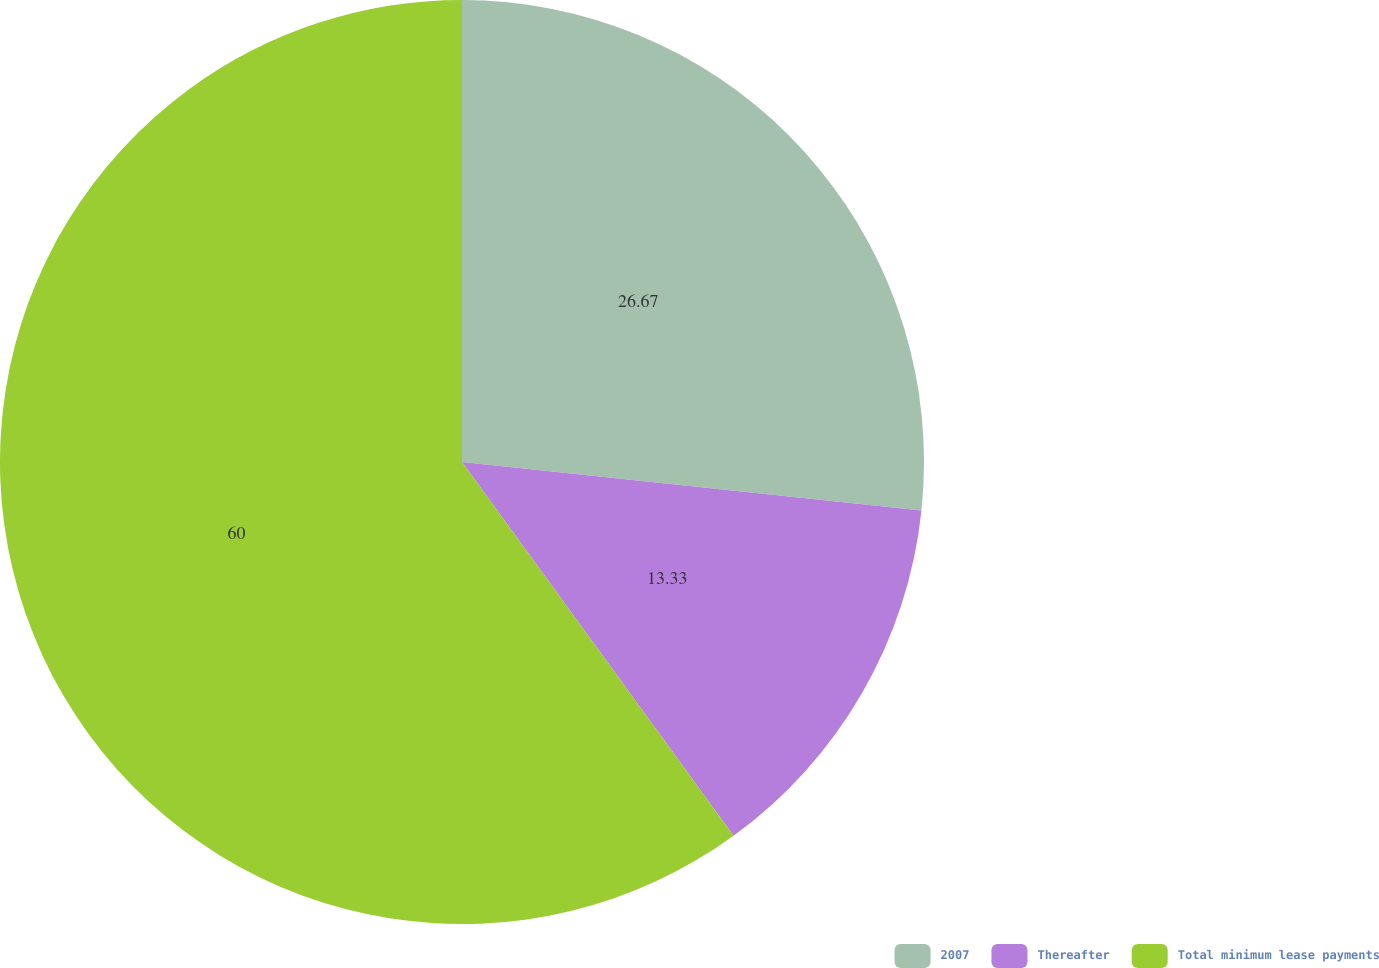Convert chart to OTSL. <chart><loc_0><loc_0><loc_500><loc_500><pie_chart><fcel>2007<fcel>Thereafter<fcel>Total minimum lease payments<nl><fcel>26.67%<fcel>13.33%<fcel>60.0%<nl></chart> 